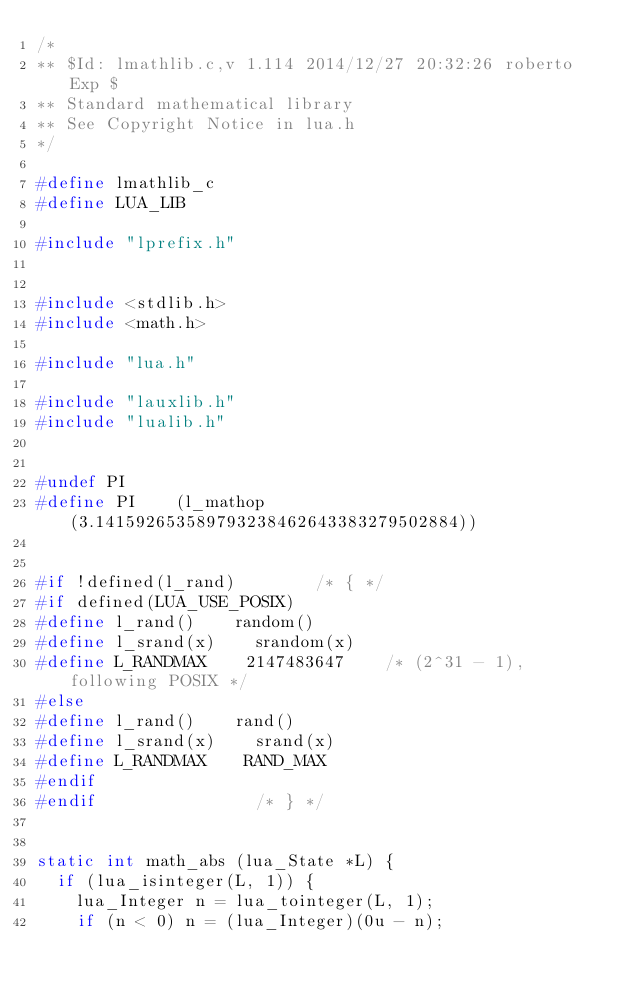<code> <loc_0><loc_0><loc_500><loc_500><_C_>/*
** $Id: lmathlib.c,v 1.114 2014/12/27 20:32:26 roberto Exp $
** Standard mathematical library
** See Copyright Notice in lua.h
*/

#define lmathlib_c
#define LUA_LIB

#include "lprefix.h"


#include <stdlib.h>
#include <math.h>

#include "lua.h"

#include "lauxlib.h"
#include "lualib.h"


#undef PI
#define PI    (l_mathop(3.141592653589793238462643383279502884))


#if !defined(l_rand)        /* { */
#if defined(LUA_USE_POSIX)
#define l_rand()    random()
#define l_srand(x)    srandom(x)
#define L_RANDMAX    2147483647    /* (2^31 - 1), following POSIX */
#else
#define l_rand()    rand()
#define l_srand(x)    srand(x)
#define L_RANDMAX    RAND_MAX
#endif
#endif                /* } */


static int math_abs (lua_State *L) {
  if (lua_isinteger(L, 1)) {
    lua_Integer n = lua_tointeger(L, 1);
    if (n < 0) n = (lua_Integer)(0u - n);</code> 